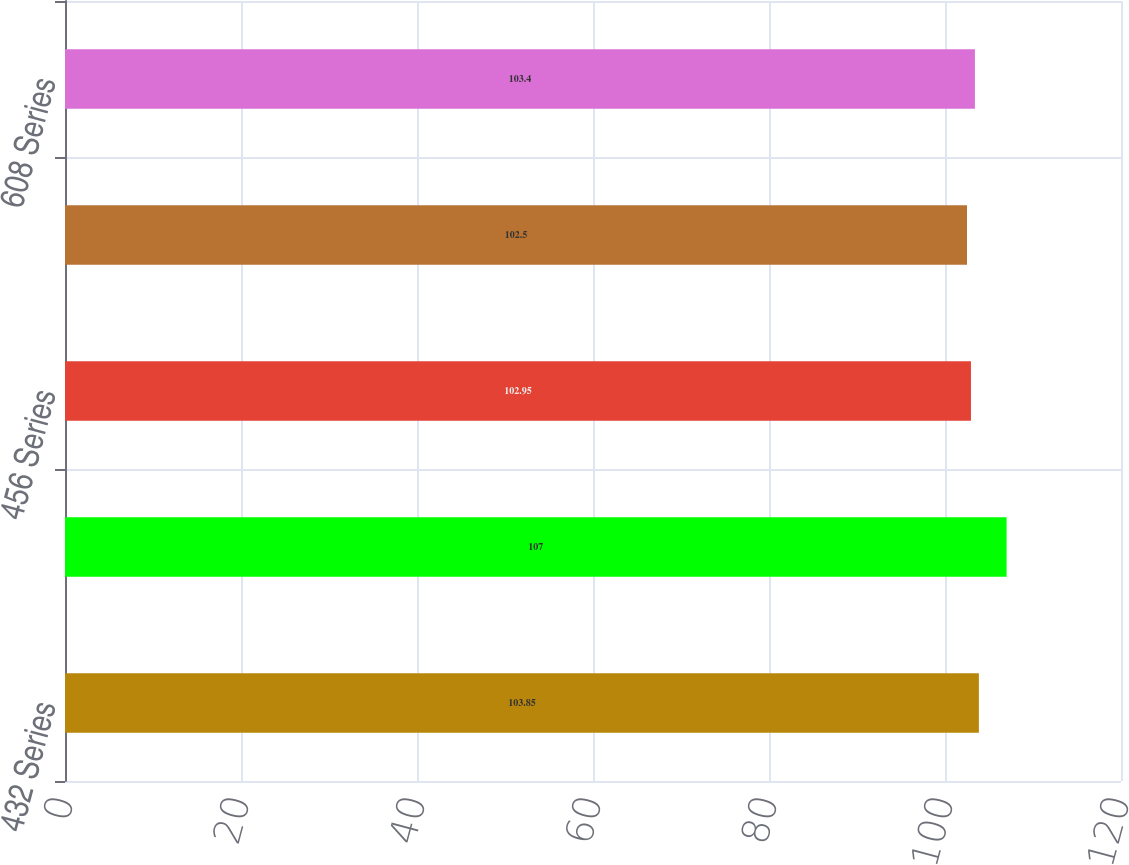Convert chart to OTSL. <chart><loc_0><loc_0><loc_500><loc_500><bar_chart><fcel>432 Series<fcel>472 Series<fcel>456 Series<fcel>456 1965 Series<fcel>608 Series<nl><fcel>103.85<fcel>107<fcel>102.95<fcel>102.5<fcel>103.4<nl></chart> 